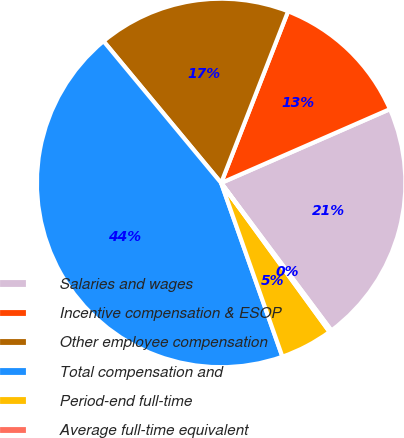Convert chart to OTSL. <chart><loc_0><loc_0><loc_500><loc_500><pie_chart><fcel>Salaries and wages<fcel>Incentive compensation & ESOP<fcel>Other employee compensation<fcel>Total compensation and<fcel>Period-end full-time<fcel>Average full-time equivalent<nl><fcel>21.35%<fcel>12.52%<fcel>16.94%<fcel>44.37%<fcel>4.62%<fcel>0.2%<nl></chart> 